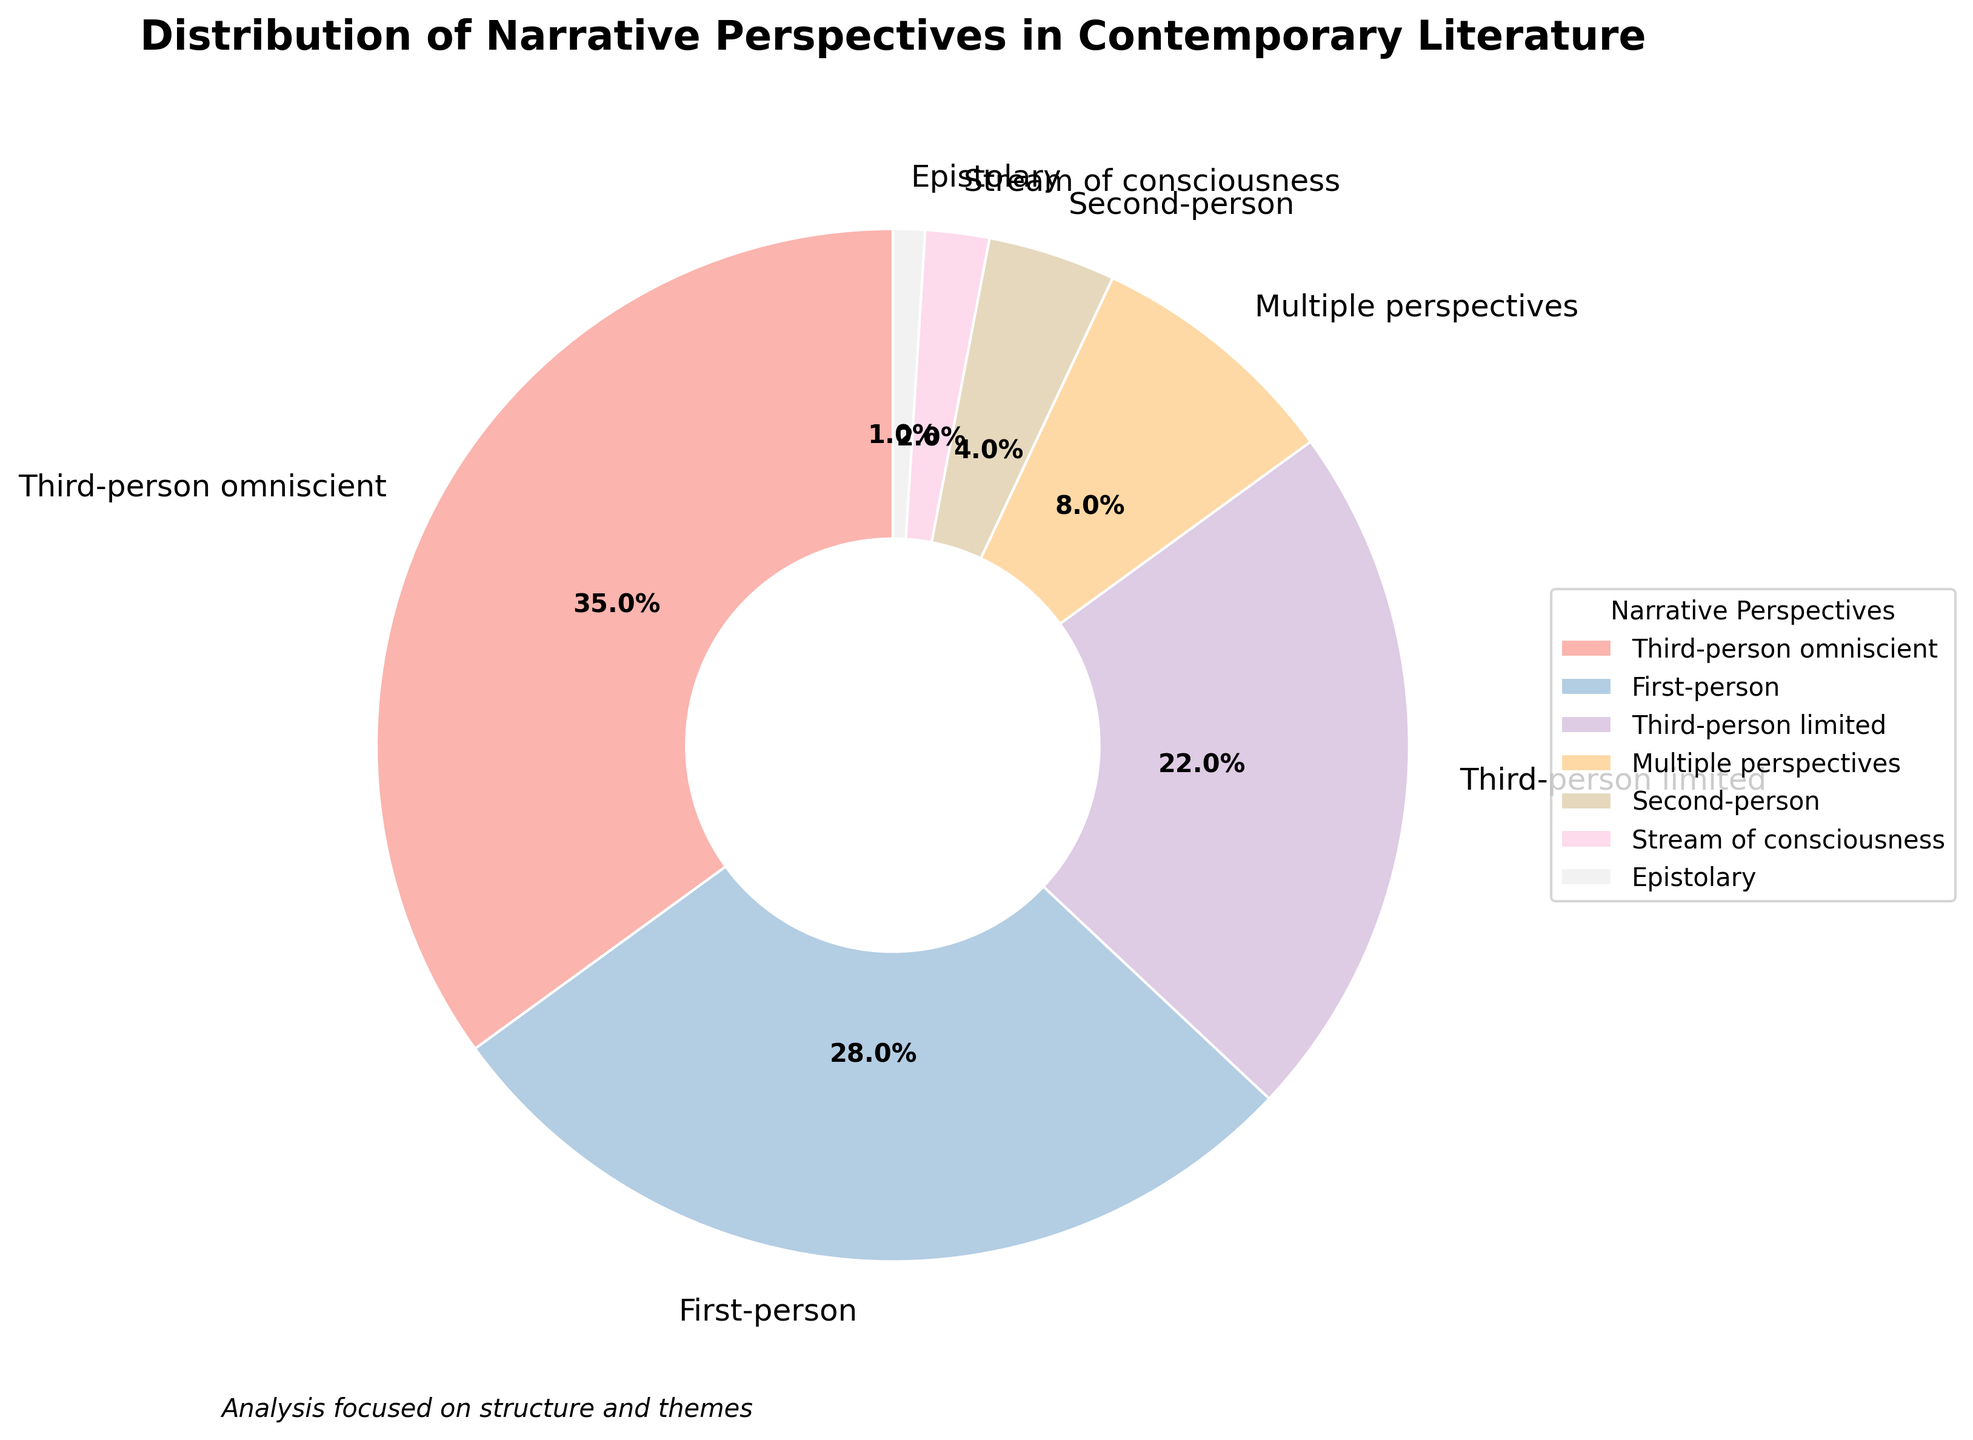What's the percentage of narrative perspectives that use the first-person view? Look for the segment labeled "First-person" and refer to the percentage associated with it.
Answer: 28% What's the combined percentage of narrative perspectives that use both third-person limited and third-person omniscient views? Add the percentages for "Third-person limited" (22%) and "Third-person omniscient" (35%). 22 + 35 = 57%.
Answer: 57% How does the percentage of epistolary narratives compare to second-person narratives? Compare the percentages for "Epistolary" (1%) and "Second-person" (4%). 1% is less than 4%.
Answer: Epistolary is less than Second-person Which narrative perspective has the smallest percentage and what is that percentage? Find the smallest percentage among all segments. "Epistolary" has the smallest percentage of 1%.
Answer: Epistolary, 1% What is the percentage difference between multiple perspectives and stream of consciousness narrative styles? Subtract the percentage of "Stream of consciousness" (2%) from "Multiple perspectives" (8%). 8 - 2 = 6%.
Answer: 6% Which segment(s) of the pie chart has a percentage higher than 25%? Look for segments with percentages higher than 25%. Both "Third-person omniscient" (35%) and "First-person" (28%) qualify.
Answer: Third-person omniscient, First-person Which narrative perspective is depicted in the segment that starts at the top and goes counterclockwise? The segment that starts at the top is generally located at the start angle. Given that the start angle is 90 degrees, look counterclockwise to identify "Third-person omniscient".
Answer: Third-person omniscient How many narrative perspectives have a percentage less than 10%? Count the segments with percentages less than 10%. There are "Second-person" (4%), "Stream of consciousness" (2%), and "Epistolary" (1%), totaling three perspectives.
Answer: 3 Is the percentage of first-person narratives more than twice that of second-person narratives? Compare 28% for "First-person" to twice 4% for "Second-person". 28% is indeed more than 8%.
Answer: Yes 